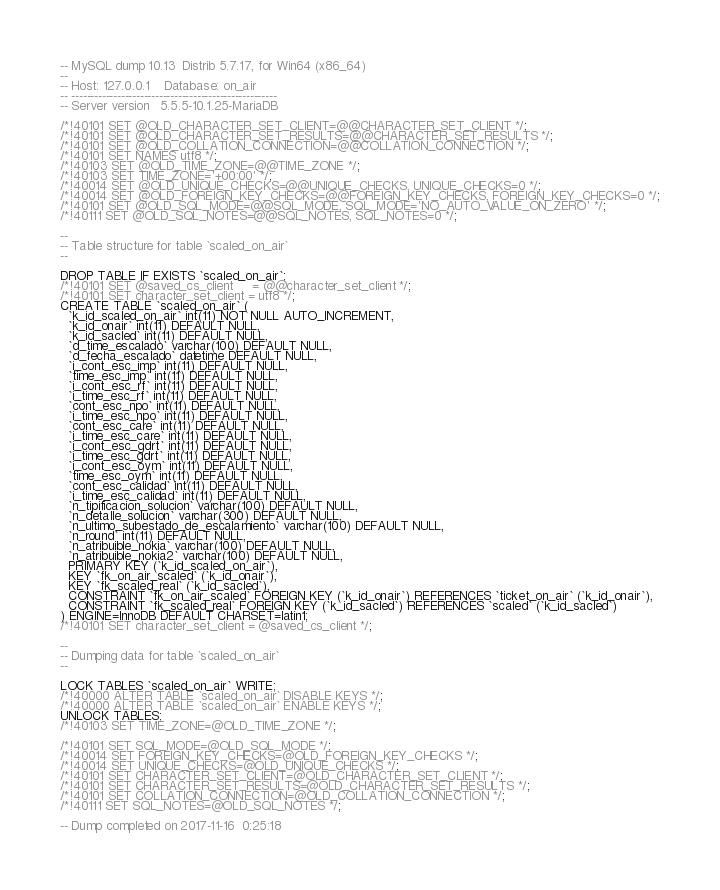Convert code to text. <code><loc_0><loc_0><loc_500><loc_500><_SQL_>-- MySQL dump 10.13  Distrib 5.7.17, for Win64 (x86_64)
--
-- Host: 127.0.0.1    Database: on_air
-- ------------------------------------------------------
-- Server version	5.5.5-10.1.25-MariaDB

/*!40101 SET @OLD_CHARACTER_SET_CLIENT=@@CHARACTER_SET_CLIENT */;
/*!40101 SET @OLD_CHARACTER_SET_RESULTS=@@CHARACTER_SET_RESULTS */;
/*!40101 SET @OLD_COLLATION_CONNECTION=@@COLLATION_CONNECTION */;
/*!40101 SET NAMES utf8 */;
/*!40103 SET @OLD_TIME_ZONE=@@TIME_ZONE */;
/*!40103 SET TIME_ZONE='+00:00' */;
/*!40014 SET @OLD_UNIQUE_CHECKS=@@UNIQUE_CHECKS, UNIQUE_CHECKS=0 */;
/*!40014 SET @OLD_FOREIGN_KEY_CHECKS=@@FOREIGN_KEY_CHECKS, FOREIGN_KEY_CHECKS=0 */;
/*!40101 SET @OLD_SQL_MODE=@@SQL_MODE, SQL_MODE='NO_AUTO_VALUE_ON_ZERO' */;
/*!40111 SET @OLD_SQL_NOTES=@@SQL_NOTES, SQL_NOTES=0 */;

--
-- Table structure for table `scaled_on_air`
--

DROP TABLE IF EXISTS `scaled_on_air`;
/*!40101 SET @saved_cs_client     = @@character_set_client */;
/*!40101 SET character_set_client = utf8 */;
CREATE TABLE `scaled_on_air` (
  `k_id_scaled_on_air` int(11) NOT NULL AUTO_INCREMENT,
  `k_id_onair` int(11) DEFAULT NULL,
  `k_id_sacled` int(11) DEFAULT NULL,
  `d_time_escalado` varchar(100) DEFAULT NULL,
  `d_fecha_escalado` datetime DEFAULT NULL,
  `i_cont_esc_imp` int(11) DEFAULT NULL,
  `time_esc_imp` int(11) DEFAULT NULL,
  `i_cont_esc_rf` int(11) DEFAULT NULL,
  `i_time_esc_rf` int(11) DEFAULT NULL,
  `cont_esc_npo` int(11) DEFAULT NULL,
  `i_time_esc_npo` int(11) DEFAULT NULL,
  `cont_esc_care` int(11) DEFAULT NULL,
  `i_time_esc_care` int(11) DEFAULT NULL,
  `i_cont_esc_gdrt` int(11) DEFAULT NULL,
  `i_time_esc_gdrt` int(11) DEFAULT NULL,
  `i_cont_esc_oym` int(11) DEFAULT NULL,
  `time_esc_oym` int(11) DEFAULT NULL,
  `cont_esc_calidad` int(11) DEFAULT NULL,
  `i_time_esc_calidad` int(11) DEFAULT NULL,
  `n_tipificacion_solucion` varchar(100) DEFAULT NULL,
  `n_detalle_solucion` varchar(300) DEFAULT NULL,
  `n_ultimo_subestado_de_escalamiento` varchar(100) DEFAULT NULL,
  `n_round` int(11) DEFAULT NULL,
  `n_atribuible_nokia` varchar(100) DEFAULT NULL,
  `n_atribuible_nokia2` varchar(100) DEFAULT NULL,
  PRIMARY KEY (`k_id_scaled_on_air`),
  KEY `fk_on_air_scaled` (`k_id_onair`),
  KEY `fk_scaled_real` (`k_id_sacled`),
  CONSTRAINT `fk_on_air_scaled` FOREIGN KEY (`k_id_onair`) REFERENCES `ticket_on_air` (`k_id_onair`),
  CONSTRAINT `fk_scaled_real` FOREIGN KEY (`k_id_sacled`) REFERENCES `scaled` (`k_id_sacled`)
) ENGINE=InnoDB DEFAULT CHARSET=latin1;
/*!40101 SET character_set_client = @saved_cs_client */;

--
-- Dumping data for table `scaled_on_air`
--

LOCK TABLES `scaled_on_air` WRITE;
/*!40000 ALTER TABLE `scaled_on_air` DISABLE KEYS */;
/*!40000 ALTER TABLE `scaled_on_air` ENABLE KEYS */;
UNLOCK TABLES;
/*!40103 SET TIME_ZONE=@OLD_TIME_ZONE */;

/*!40101 SET SQL_MODE=@OLD_SQL_MODE */;
/*!40014 SET FOREIGN_KEY_CHECKS=@OLD_FOREIGN_KEY_CHECKS */;
/*!40014 SET UNIQUE_CHECKS=@OLD_UNIQUE_CHECKS */;
/*!40101 SET CHARACTER_SET_CLIENT=@OLD_CHARACTER_SET_CLIENT */;
/*!40101 SET CHARACTER_SET_RESULTS=@OLD_CHARACTER_SET_RESULTS */;
/*!40101 SET COLLATION_CONNECTION=@OLD_COLLATION_CONNECTION */;
/*!40111 SET SQL_NOTES=@OLD_SQL_NOTES */;

-- Dump completed on 2017-11-16  0:25:18
</code> 